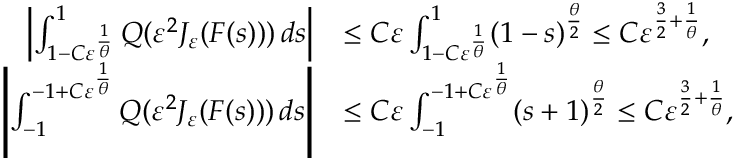<formula> <loc_0><loc_0><loc_500><loc_500>\begin{array} { r l } { \left | \int _ { 1 - C \varepsilon ^ { \frac { 1 } \theta } } } ^ { 1 } Q ( \varepsilon ^ { 2 } J _ { \varepsilon } ( F ( s ) ) ) \, d s \right | } & { \leq C \varepsilon \int _ { 1 - C \varepsilon ^ { \frac { 1 } \theta } } } ^ { 1 } ( 1 - s ) ^ { \frac { \theta } { 2 } } \leq C \varepsilon ^ { \frac { 3 } { 2 } + \frac { 1 } { \theta } } , } \\ { \left | \int _ { - 1 } ^ { - 1 + C \varepsilon ^ { \frac { 1 } \theta } } } Q ( \varepsilon ^ { 2 } J _ { \varepsilon } ( F ( s ) ) ) \, d s \right | } & { \leq C \varepsilon \int _ { - 1 } ^ { - 1 + C \varepsilon ^ { \frac { 1 } \theta } } } ( s + 1 ) ^ { \frac { \theta } { 2 } } \leq C \varepsilon ^ { \frac { 3 } { 2 } + \frac { 1 } { \theta } } , } \end{array}</formula> 